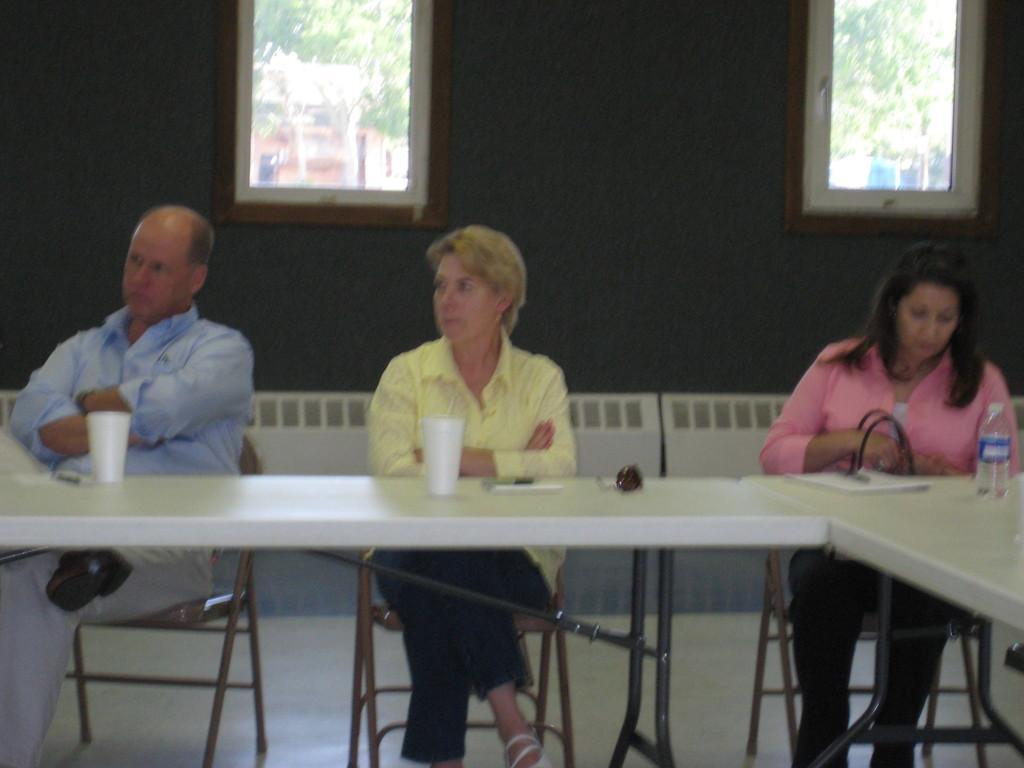In one or two sentences, can you explain what this image depicts? There are three people sitting in chair at a table. Of them two are women and one is a man. There two glasses and a water bottle on the table. There are two windows on to the wall behind of them. Through windows we can see some trees in the background. 